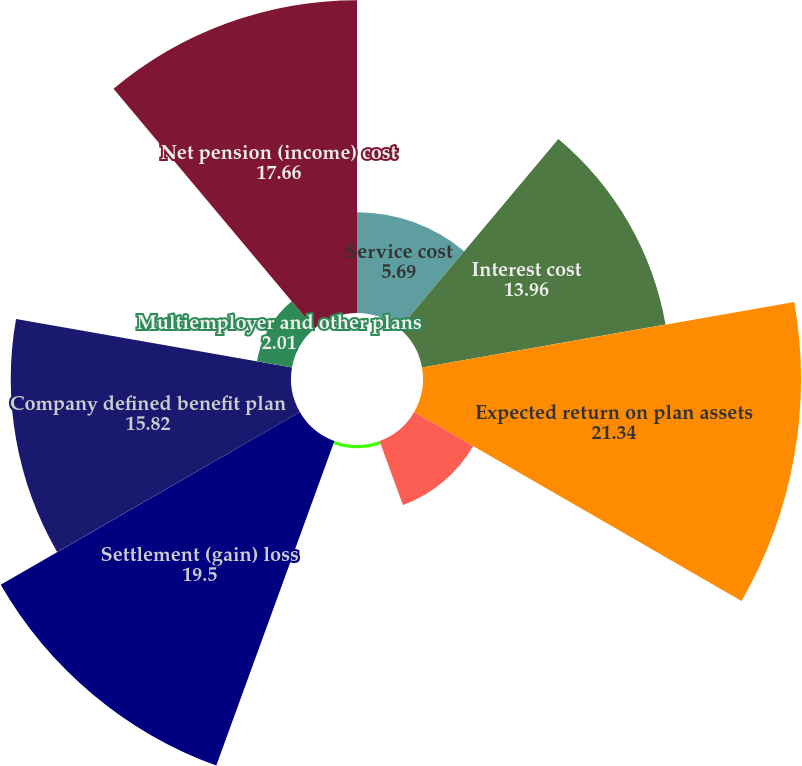Convert chart to OTSL. <chart><loc_0><loc_0><loc_500><loc_500><pie_chart><fcel>Service cost<fcel>Interest cost<fcel>Expected return on plan assets<fcel>A Amortization of net<fcel>A Amortization of prior<fcel>Settlement (gain) loss<fcel>Company defined benefit plan<fcel>Multiemployer and other plans<fcel>Net pension (income) cost<nl><fcel>5.69%<fcel>13.96%<fcel>21.34%<fcel>3.85%<fcel>0.18%<fcel>19.5%<fcel>15.82%<fcel>2.01%<fcel>17.66%<nl></chart> 